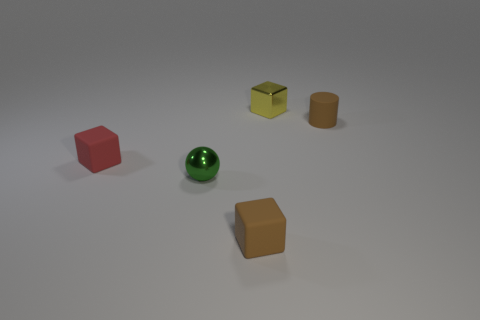Are there more shiny cubes on the left side of the small metal ball than tiny cylinders?
Make the answer very short. No. What is the shape of the tiny rubber object that is behind the red block?
Your answer should be very brief. Cylinder. What number of other things are the same shape as the small red thing?
Offer a terse response. 2. Is the material of the tiny block in front of the small red thing the same as the small red object?
Offer a terse response. Yes. Are there the same number of small red matte things that are behind the yellow shiny thing and small brown cylinders that are on the left side of the green thing?
Your answer should be very brief. Yes. What is the size of the rubber block on the left side of the small metal sphere?
Provide a succinct answer. Small. Is there a tiny red cube that has the same material as the yellow block?
Offer a very short reply. No. Is the color of the tiny rubber object that is right of the yellow metal block the same as the shiny cube?
Your answer should be compact. No. Are there the same number of yellow blocks that are left of the tiny yellow metallic block and small blue metallic cubes?
Ensure brevity in your answer.  Yes. Is there a tiny rubber cube that has the same color as the small matte cylinder?
Your response must be concise. Yes. 